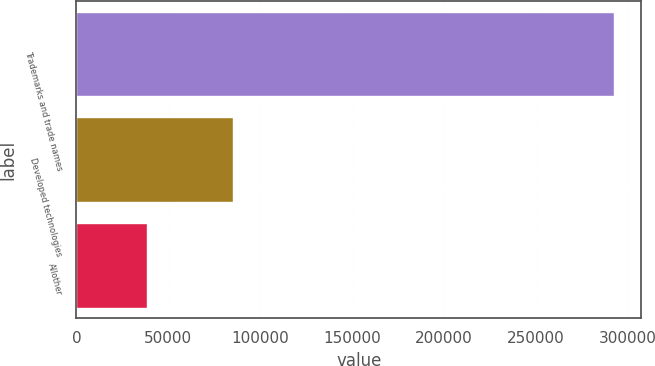Convert chart. <chart><loc_0><loc_0><loc_500><loc_500><bar_chart><fcel>Trademarks and trade names<fcel>Developed technologies<fcel>Allother<nl><fcel>292854<fcel>85441<fcel>38546<nl></chart> 